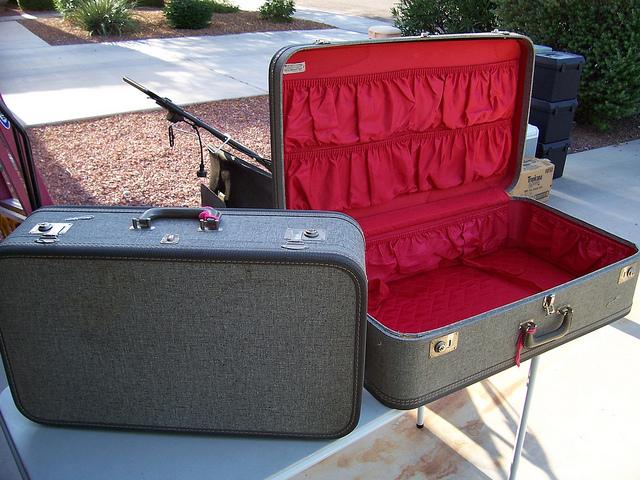Are Is this luggage scuffed up?
Keep it brief. No. What color is the liner in the open suitcase?
Quick response, please. Red. Are the suitcases on the ground?
Give a very brief answer. No. What color is the yarn on the handle of each suitcase?
Quick response, please. Red. 